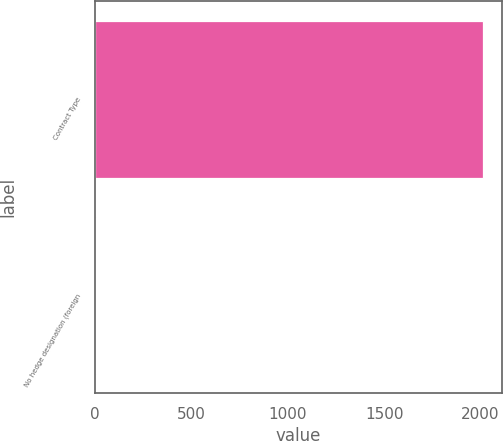Convert chart to OTSL. <chart><loc_0><loc_0><loc_500><loc_500><bar_chart><fcel>Contract Type<fcel>No hedge designation (foreign<nl><fcel>2010<fcel>5<nl></chart> 